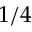<formula> <loc_0><loc_0><loc_500><loc_500>1 / 4</formula> 